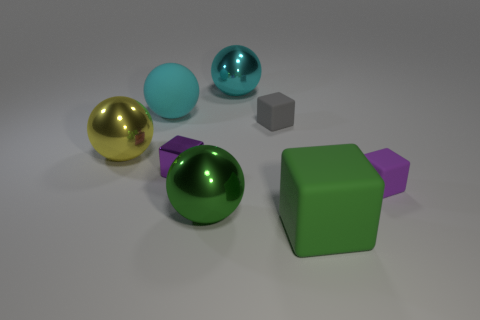What number of other objects are the same color as the big matte sphere?
Give a very brief answer. 1. What is the green cube made of?
Your response must be concise. Rubber. Are there any purple rubber things?
Make the answer very short. Yes. Are there an equal number of cyan objects that are in front of the cyan rubber ball and big cyan metal objects?
Your answer should be compact. No. Is there any other thing that has the same material as the big yellow ball?
Keep it short and to the point. Yes. How many large things are green rubber blocks or purple cubes?
Make the answer very short. 1. What is the shape of the matte object that is the same color as the metal block?
Offer a terse response. Cube. Is the material of the purple object that is in front of the small purple metal thing the same as the yellow thing?
Ensure brevity in your answer.  No. There is a purple object that is left of the block that is behind the tiny purple metal thing; what is it made of?
Offer a terse response. Metal. How many large yellow metal things are the same shape as the large cyan rubber thing?
Offer a very short reply. 1. 